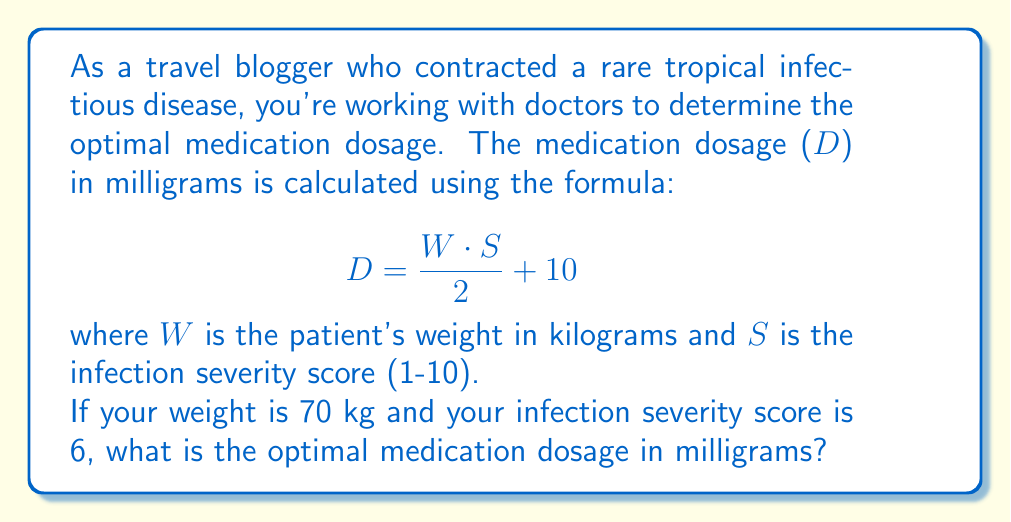Solve this math problem. To solve this problem, we'll follow these steps:

1. Identify the given information:
   - Weight (W) = 70 kg
   - Severity score (S) = 6
   - Formula: $D = \frac{W \cdot S}{2} + 10$

2. Substitute the values into the formula:
   $$D = \frac{70 \cdot 6}{2} + 10$$

3. Solve the equation:
   a. First, multiply 70 and 6:
      $$D = \frac{420}{2} + 10$$
   
   b. Divide 420 by 2:
      $$D = 210 + 10$$
   
   c. Add 210 and 10:
      $$D = 220$$

Therefore, the optimal medication dosage is 220 milligrams.
Answer: 220 mg 